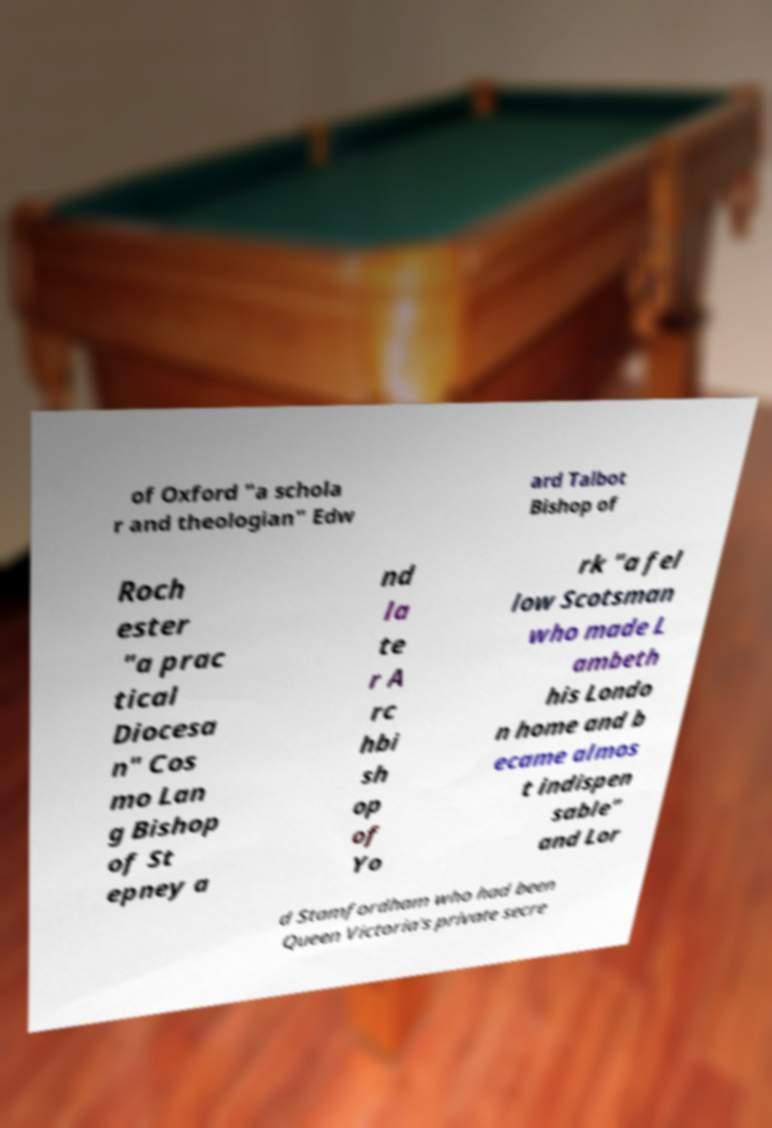Can you accurately transcribe the text from the provided image for me? of Oxford "a schola r and theologian" Edw ard Talbot Bishop of Roch ester "a prac tical Diocesa n" Cos mo Lan g Bishop of St epney a nd la te r A rc hbi sh op of Yo rk "a fel low Scotsman who made L ambeth his Londo n home and b ecame almos t indispen sable" and Lor d Stamfordham who had been Queen Victoria's private secre 